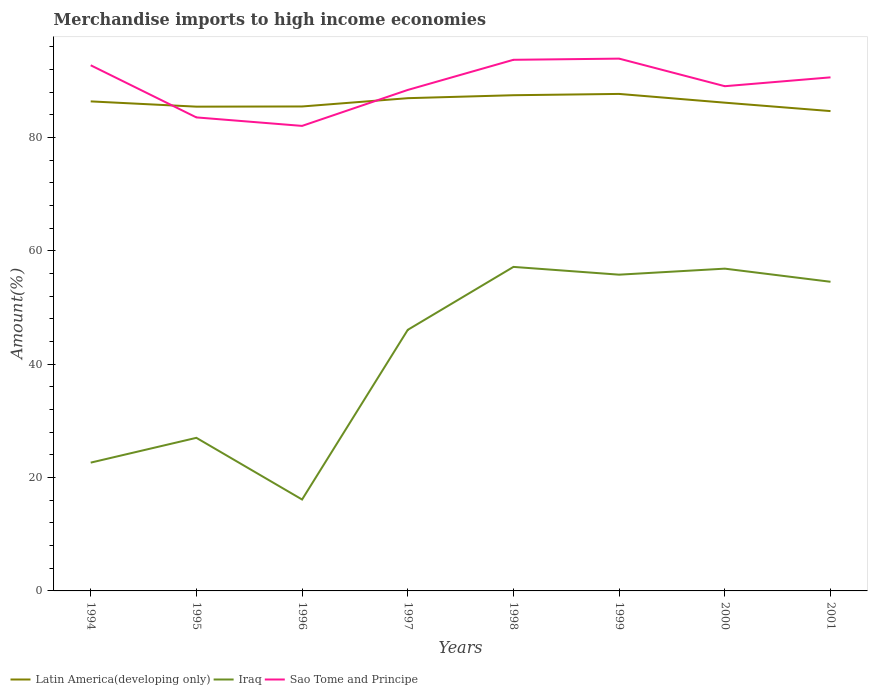Does the line corresponding to Sao Tome and Principe intersect with the line corresponding to Latin America(developing only)?
Provide a short and direct response. Yes. Across all years, what is the maximum percentage of amount earned from merchandise imports in Sao Tome and Principe?
Make the answer very short. 82.06. What is the total percentage of amount earned from merchandise imports in Sao Tome and Principe in the graph?
Provide a short and direct response. 10.7. What is the difference between the highest and the second highest percentage of amount earned from merchandise imports in Sao Tome and Principe?
Ensure brevity in your answer.  11.87. Is the percentage of amount earned from merchandise imports in Sao Tome and Principe strictly greater than the percentage of amount earned from merchandise imports in Latin America(developing only) over the years?
Provide a succinct answer. No. How many lines are there?
Provide a short and direct response. 3. How many years are there in the graph?
Ensure brevity in your answer.  8. Where does the legend appear in the graph?
Offer a very short reply. Bottom left. How are the legend labels stacked?
Keep it short and to the point. Horizontal. What is the title of the graph?
Keep it short and to the point. Merchandise imports to high income economies. What is the label or title of the X-axis?
Your answer should be compact. Years. What is the label or title of the Y-axis?
Provide a short and direct response. Amount(%). What is the Amount(%) of Latin America(developing only) in 1994?
Your answer should be very brief. 86.39. What is the Amount(%) of Iraq in 1994?
Your answer should be very brief. 22.64. What is the Amount(%) in Sao Tome and Principe in 1994?
Provide a short and direct response. 92.76. What is the Amount(%) in Latin America(developing only) in 1995?
Make the answer very short. 85.46. What is the Amount(%) in Iraq in 1995?
Your answer should be very brief. 27.02. What is the Amount(%) in Sao Tome and Principe in 1995?
Provide a short and direct response. 83.56. What is the Amount(%) of Latin America(developing only) in 1996?
Your answer should be compact. 85.49. What is the Amount(%) of Iraq in 1996?
Your response must be concise. 16.13. What is the Amount(%) of Sao Tome and Principe in 1996?
Your answer should be compact. 82.06. What is the Amount(%) in Latin America(developing only) in 1997?
Make the answer very short. 86.96. What is the Amount(%) of Iraq in 1997?
Offer a very short reply. 46.07. What is the Amount(%) of Sao Tome and Principe in 1997?
Provide a succinct answer. 88.41. What is the Amount(%) of Latin America(developing only) in 1998?
Provide a succinct answer. 87.48. What is the Amount(%) in Iraq in 1998?
Your answer should be very brief. 57.18. What is the Amount(%) in Sao Tome and Principe in 1998?
Offer a very short reply. 93.73. What is the Amount(%) of Latin America(developing only) in 1999?
Ensure brevity in your answer.  87.71. What is the Amount(%) in Iraq in 1999?
Provide a succinct answer. 55.81. What is the Amount(%) of Sao Tome and Principe in 1999?
Your response must be concise. 93.94. What is the Amount(%) of Latin America(developing only) in 2000?
Give a very brief answer. 86.16. What is the Amount(%) of Iraq in 2000?
Offer a terse response. 56.87. What is the Amount(%) of Sao Tome and Principe in 2000?
Provide a short and direct response. 89.07. What is the Amount(%) of Latin America(developing only) in 2001?
Your answer should be compact. 84.68. What is the Amount(%) in Iraq in 2001?
Your answer should be very brief. 54.56. What is the Amount(%) in Sao Tome and Principe in 2001?
Provide a short and direct response. 90.63. Across all years, what is the maximum Amount(%) of Latin America(developing only)?
Provide a succinct answer. 87.71. Across all years, what is the maximum Amount(%) of Iraq?
Give a very brief answer. 57.18. Across all years, what is the maximum Amount(%) in Sao Tome and Principe?
Offer a terse response. 93.94. Across all years, what is the minimum Amount(%) in Latin America(developing only)?
Offer a terse response. 84.68. Across all years, what is the minimum Amount(%) of Iraq?
Offer a terse response. 16.13. Across all years, what is the minimum Amount(%) in Sao Tome and Principe?
Your response must be concise. 82.06. What is the total Amount(%) of Latin America(developing only) in the graph?
Provide a succinct answer. 690.32. What is the total Amount(%) of Iraq in the graph?
Offer a very short reply. 336.28. What is the total Amount(%) of Sao Tome and Principe in the graph?
Your response must be concise. 714.16. What is the difference between the Amount(%) in Latin America(developing only) in 1994 and that in 1995?
Provide a succinct answer. 0.93. What is the difference between the Amount(%) in Iraq in 1994 and that in 1995?
Your answer should be very brief. -4.38. What is the difference between the Amount(%) of Sao Tome and Principe in 1994 and that in 1995?
Provide a succinct answer. 9.2. What is the difference between the Amount(%) of Latin America(developing only) in 1994 and that in 1996?
Give a very brief answer. 0.9. What is the difference between the Amount(%) in Iraq in 1994 and that in 1996?
Provide a succinct answer. 6.51. What is the difference between the Amount(%) in Sao Tome and Principe in 1994 and that in 1996?
Make the answer very short. 10.7. What is the difference between the Amount(%) in Latin America(developing only) in 1994 and that in 1997?
Offer a terse response. -0.57. What is the difference between the Amount(%) of Iraq in 1994 and that in 1997?
Give a very brief answer. -23.43. What is the difference between the Amount(%) in Sao Tome and Principe in 1994 and that in 1997?
Ensure brevity in your answer.  4.35. What is the difference between the Amount(%) of Latin America(developing only) in 1994 and that in 1998?
Provide a short and direct response. -1.09. What is the difference between the Amount(%) in Iraq in 1994 and that in 1998?
Give a very brief answer. -34.54. What is the difference between the Amount(%) in Sao Tome and Principe in 1994 and that in 1998?
Your answer should be very brief. -0.97. What is the difference between the Amount(%) of Latin America(developing only) in 1994 and that in 1999?
Keep it short and to the point. -1.32. What is the difference between the Amount(%) of Iraq in 1994 and that in 1999?
Your answer should be compact. -33.17. What is the difference between the Amount(%) in Sao Tome and Principe in 1994 and that in 1999?
Make the answer very short. -1.17. What is the difference between the Amount(%) in Latin America(developing only) in 1994 and that in 2000?
Your response must be concise. 0.23. What is the difference between the Amount(%) in Iraq in 1994 and that in 2000?
Your answer should be very brief. -34.23. What is the difference between the Amount(%) in Sao Tome and Principe in 1994 and that in 2000?
Provide a succinct answer. 3.69. What is the difference between the Amount(%) of Latin America(developing only) in 1994 and that in 2001?
Ensure brevity in your answer.  1.71. What is the difference between the Amount(%) in Iraq in 1994 and that in 2001?
Your answer should be very brief. -31.92. What is the difference between the Amount(%) of Sao Tome and Principe in 1994 and that in 2001?
Ensure brevity in your answer.  2.13. What is the difference between the Amount(%) of Latin America(developing only) in 1995 and that in 1996?
Your answer should be very brief. -0.03. What is the difference between the Amount(%) in Iraq in 1995 and that in 1996?
Your answer should be very brief. 10.89. What is the difference between the Amount(%) of Sao Tome and Principe in 1995 and that in 1996?
Offer a terse response. 1.5. What is the difference between the Amount(%) in Latin America(developing only) in 1995 and that in 1997?
Provide a succinct answer. -1.5. What is the difference between the Amount(%) in Iraq in 1995 and that in 1997?
Your answer should be compact. -19.06. What is the difference between the Amount(%) in Sao Tome and Principe in 1995 and that in 1997?
Make the answer very short. -4.85. What is the difference between the Amount(%) in Latin America(developing only) in 1995 and that in 1998?
Offer a very short reply. -2.02. What is the difference between the Amount(%) in Iraq in 1995 and that in 1998?
Offer a terse response. -30.17. What is the difference between the Amount(%) in Sao Tome and Principe in 1995 and that in 1998?
Provide a succinct answer. -10.17. What is the difference between the Amount(%) in Latin America(developing only) in 1995 and that in 1999?
Keep it short and to the point. -2.25. What is the difference between the Amount(%) of Iraq in 1995 and that in 1999?
Provide a short and direct response. -28.79. What is the difference between the Amount(%) of Sao Tome and Principe in 1995 and that in 1999?
Provide a succinct answer. -10.37. What is the difference between the Amount(%) of Latin America(developing only) in 1995 and that in 2000?
Your answer should be compact. -0.7. What is the difference between the Amount(%) in Iraq in 1995 and that in 2000?
Your response must be concise. -29.86. What is the difference between the Amount(%) in Sao Tome and Principe in 1995 and that in 2000?
Provide a short and direct response. -5.51. What is the difference between the Amount(%) in Latin America(developing only) in 1995 and that in 2001?
Offer a very short reply. 0.78. What is the difference between the Amount(%) in Iraq in 1995 and that in 2001?
Give a very brief answer. -27.54. What is the difference between the Amount(%) of Sao Tome and Principe in 1995 and that in 2001?
Keep it short and to the point. -7.07. What is the difference between the Amount(%) in Latin America(developing only) in 1996 and that in 1997?
Ensure brevity in your answer.  -1.46. What is the difference between the Amount(%) in Iraq in 1996 and that in 1997?
Offer a terse response. -29.94. What is the difference between the Amount(%) in Sao Tome and Principe in 1996 and that in 1997?
Your response must be concise. -6.34. What is the difference between the Amount(%) in Latin America(developing only) in 1996 and that in 1998?
Make the answer very short. -1.99. What is the difference between the Amount(%) of Iraq in 1996 and that in 1998?
Offer a terse response. -41.05. What is the difference between the Amount(%) in Sao Tome and Principe in 1996 and that in 1998?
Keep it short and to the point. -11.67. What is the difference between the Amount(%) of Latin America(developing only) in 1996 and that in 1999?
Provide a succinct answer. -2.22. What is the difference between the Amount(%) in Iraq in 1996 and that in 1999?
Offer a terse response. -39.68. What is the difference between the Amount(%) of Sao Tome and Principe in 1996 and that in 1999?
Provide a short and direct response. -11.87. What is the difference between the Amount(%) of Latin America(developing only) in 1996 and that in 2000?
Offer a terse response. -0.67. What is the difference between the Amount(%) in Iraq in 1996 and that in 2000?
Ensure brevity in your answer.  -40.74. What is the difference between the Amount(%) of Sao Tome and Principe in 1996 and that in 2000?
Offer a terse response. -7. What is the difference between the Amount(%) in Latin America(developing only) in 1996 and that in 2001?
Offer a very short reply. 0.81. What is the difference between the Amount(%) of Iraq in 1996 and that in 2001?
Your answer should be compact. -38.43. What is the difference between the Amount(%) of Sao Tome and Principe in 1996 and that in 2001?
Provide a short and direct response. -8.57. What is the difference between the Amount(%) in Latin America(developing only) in 1997 and that in 1998?
Make the answer very short. -0.52. What is the difference between the Amount(%) in Iraq in 1997 and that in 1998?
Provide a succinct answer. -11.11. What is the difference between the Amount(%) in Sao Tome and Principe in 1997 and that in 1998?
Ensure brevity in your answer.  -5.32. What is the difference between the Amount(%) of Latin America(developing only) in 1997 and that in 1999?
Keep it short and to the point. -0.75. What is the difference between the Amount(%) of Iraq in 1997 and that in 1999?
Make the answer very short. -9.74. What is the difference between the Amount(%) of Sao Tome and Principe in 1997 and that in 1999?
Your response must be concise. -5.53. What is the difference between the Amount(%) in Latin America(developing only) in 1997 and that in 2000?
Keep it short and to the point. 0.79. What is the difference between the Amount(%) in Iraq in 1997 and that in 2000?
Your answer should be compact. -10.8. What is the difference between the Amount(%) in Sao Tome and Principe in 1997 and that in 2000?
Provide a short and direct response. -0.66. What is the difference between the Amount(%) in Latin America(developing only) in 1997 and that in 2001?
Provide a succinct answer. 2.28. What is the difference between the Amount(%) of Iraq in 1997 and that in 2001?
Keep it short and to the point. -8.48. What is the difference between the Amount(%) in Sao Tome and Principe in 1997 and that in 2001?
Your response must be concise. -2.22. What is the difference between the Amount(%) in Latin America(developing only) in 1998 and that in 1999?
Offer a terse response. -0.23. What is the difference between the Amount(%) of Iraq in 1998 and that in 1999?
Your answer should be very brief. 1.37. What is the difference between the Amount(%) in Sao Tome and Principe in 1998 and that in 1999?
Give a very brief answer. -0.21. What is the difference between the Amount(%) in Latin America(developing only) in 1998 and that in 2000?
Your answer should be compact. 1.32. What is the difference between the Amount(%) of Iraq in 1998 and that in 2000?
Keep it short and to the point. 0.31. What is the difference between the Amount(%) of Sao Tome and Principe in 1998 and that in 2000?
Provide a short and direct response. 4.66. What is the difference between the Amount(%) of Latin America(developing only) in 1998 and that in 2001?
Keep it short and to the point. 2.8. What is the difference between the Amount(%) in Iraq in 1998 and that in 2001?
Your response must be concise. 2.62. What is the difference between the Amount(%) in Sao Tome and Principe in 1998 and that in 2001?
Your answer should be very brief. 3.1. What is the difference between the Amount(%) of Latin America(developing only) in 1999 and that in 2000?
Offer a very short reply. 1.54. What is the difference between the Amount(%) in Iraq in 1999 and that in 2000?
Give a very brief answer. -1.06. What is the difference between the Amount(%) in Sao Tome and Principe in 1999 and that in 2000?
Your answer should be compact. 4.87. What is the difference between the Amount(%) in Latin America(developing only) in 1999 and that in 2001?
Provide a short and direct response. 3.03. What is the difference between the Amount(%) in Iraq in 1999 and that in 2001?
Your answer should be compact. 1.25. What is the difference between the Amount(%) in Sao Tome and Principe in 1999 and that in 2001?
Your answer should be compact. 3.31. What is the difference between the Amount(%) in Latin America(developing only) in 2000 and that in 2001?
Offer a very short reply. 1.48. What is the difference between the Amount(%) in Iraq in 2000 and that in 2001?
Keep it short and to the point. 2.32. What is the difference between the Amount(%) of Sao Tome and Principe in 2000 and that in 2001?
Provide a short and direct response. -1.56. What is the difference between the Amount(%) of Latin America(developing only) in 1994 and the Amount(%) of Iraq in 1995?
Make the answer very short. 59.37. What is the difference between the Amount(%) in Latin America(developing only) in 1994 and the Amount(%) in Sao Tome and Principe in 1995?
Provide a short and direct response. 2.83. What is the difference between the Amount(%) in Iraq in 1994 and the Amount(%) in Sao Tome and Principe in 1995?
Your answer should be compact. -60.92. What is the difference between the Amount(%) in Latin America(developing only) in 1994 and the Amount(%) in Iraq in 1996?
Your answer should be very brief. 70.26. What is the difference between the Amount(%) of Latin America(developing only) in 1994 and the Amount(%) of Sao Tome and Principe in 1996?
Give a very brief answer. 4.32. What is the difference between the Amount(%) of Iraq in 1994 and the Amount(%) of Sao Tome and Principe in 1996?
Make the answer very short. -59.42. What is the difference between the Amount(%) in Latin America(developing only) in 1994 and the Amount(%) in Iraq in 1997?
Give a very brief answer. 40.32. What is the difference between the Amount(%) of Latin America(developing only) in 1994 and the Amount(%) of Sao Tome and Principe in 1997?
Ensure brevity in your answer.  -2.02. What is the difference between the Amount(%) of Iraq in 1994 and the Amount(%) of Sao Tome and Principe in 1997?
Your answer should be compact. -65.77. What is the difference between the Amount(%) of Latin America(developing only) in 1994 and the Amount(%) of Iraq in 1998?
Your response must be concise. 29.21. What is the difference between the Amount(%) of Latin America(developing only) in 1994 and the Amount(%) of Sao Tome and Principe in 1998?
Your answer should be very brief. -7.34. What is the difference between the Amount(%) of Iraq in 1994 and the Amount(%) of Sao Tome and Principe in 1998?
Offer a very short reply. -71.09. What is the difference between the Amount(%) in Latin America(developing only) in 1994 and the Amount(%) in Iraq in 1999?
Give a very brief answer. 30.58. What is the difference between the Amount(%) in Latin America(developing only) in 1994 and the Amount(%) in Sao Tome and Principe in 1999?
Make the answer very short. -7.55. What is the difference between the Amount(%) in Iraq in 1994 and the Amount(%) in Sao Tome and Principe in 1999?
Offer a very short reply. -71.3. What is the difference between the Amount(%) in Latin America(developing only) in 1994 and the Amount(%) in Iraq in 2000?
Make the answer very short. 29.52. What is the difference between the Amount(%) in Latin America(developing only) in 1994 and the Amount(%) in Sao Tome and Principe in 2000?
Offer a very short reply. -2.68. What is the difference between the Amount(%) of Iraq in 1994 and the Amount(%) of Sao Tome and Principe in 2000?
Ensure brevity in your answer.  -66.43. What is the difference between the Amount(%) of Latin America(developing only) in 1994 and the Amount(%) of Iraq in 2001?
Your response must be concise. 31.83. What is the difference between the Amount(%) in Latin America(developing only) in 1994 and the Amount(%) in Sao Tome and Principe in 2001?
Offer a terse response. -4.24. What is the difference between the Amount(%) of Iraq in 1994 and the Amount(%) of Sao Tome and Principe in 2001?
Offer a very short reply. -67.99. What is the difference between the Amount(%) of Latin America(developing only) in 1995 and the Amount(%) of Iraq in 1996?
Ensure brevity in your answer.  69.33. What is the difference between the Amount(%) of Latin America(developing only) in 1995 and the Amount(%) of Sao Tome and Principe in 1996?
Keep it short and to the point. 3.4. What is the difference between the Amount(%) in Iraq in 1995 and the Amount(%) in Sao Tome and Principe in 1996?
Provide a short and direct response. -55.05. What is the difference between the Amount(%) of Latin America(developing only) in 1995 and the Amount(%) of Iraq in 1997?
Ensure brevity in your answer.  39.39. What is the difference between the Amount(%) of Latin America(developing only) in 1995 and the Amount(%) of Sao Tome and Principe in 1997?
Provide a succinct answer. -2.95. What is the difference between the Amount(%) of Iraq in 1995 and the Amount(%) of Sao Tome and Principe in 1997?
Your response must be concise. -61.39. What is the difference between the Amount(%) in Latin America(developing only) in 1995 and the Amount(%) in Iraq in 1998?
Provide a succinct answer. 28.28. What is the difference between the Amount(%) in Latin America(developing only) in 1995 and the Amount(%) in Sao Tome and Principe in 1998?
Give a very brief answer. -8.27. What is the difference between the Amount(%) in Iraq in 1995 and the Amount(%) in Sao Tome and Principe in 1998?
Make the answer very short. -66.71. What is the difference between the Amount(%) in Latin America(developing only) in 1995 and the Amount(%) in Iraq in 1999?
Offer a terse response. 29.65. What is the difference between the Amount(%) in Latin America(developing only) in 1995 and the Amount(%) in Sao Tome and Principe in 1999?
Give a very brief answer. -8.48. What is the difference between the Amount(%) of Iraq in 1995 and the Amount(%) of Sao Tome and Principe in 1999?
Your answer should be very brief. -66.92. What is the difference between the Amount(%) of Latin America(developing only) in 1995 and the Amount(%) of Iraq in 2000?
Provide a short and direct response. 28.59. What is the difference between the Amount(%) of Latin America(developing only) in 1995 and the Amount(%) of Sao Tome and Principe in 2000?
Ensure brevity in your answer.  -3.61. What is the difference between the Amount(%) of Iraq in 1995 and the Amount(%) of Sao Tome and Principe in 2000?
Ensure brevity in your answer.  -62.05. What is the difference between the Amount(%) in Latin America(developing only) in 1995 and the Amount(%) in Iraq in 2001?
Provide a succinct answer. 30.9. What is the difference between the Amount(%) in Latin America(developing only) in 1995 and the Amount(%) in Sao Tome and Principe in 2001?
Your answer should be compact. -5.17. What is the difference between the Amount(%) of Iraq in 1995 and the Amount(%) of Sao Tome and Principe in 2001?
Provide a short and direct response. -63.62. What is the difference between the Amount(%) of Latin America(developing only) in 1996 and the Amount(%) of Iraq in 1997?
Your answer should be very brief. 39.42. What is the difference between the Amount(%) of Latin America(developing only) in 1996 and the Amount(%) of Sao Tome and Principe in 1997?
Your response must be concise. -2.92. What is the difference between the Amount(%) in Iraq in 1996 and the Amount(%) in Sao Tome and Principe in 1997?
Keep it short and to the point. -72.28. What is the difference between the Amount(%) in Latin America(developing only) in 1996 and the Amount(%) in Iraq in 1998?
Make the answer very short. 28.31. What is the difference between the Amount(%) of Latin America(developing only) in 1996 and the Amount(%) of Sao Tome and Principe in 1998?
Keep it short and to the point. -8.24. What is the difference between the Amount(%) of Iraq in 1996 and the Amount(%) of Sao Tome and Principe in 1998?
Ensure brevity in your answer.  -77.6. What is the difference between the Amount(%) in Latin America(developing only) in 1996 and the Amount(%) in Iraq in 1999?
Your answer should be compact. 29.68. What is the difference between the Amount(%) in Latin America(developing only) in 1996 and the Amount(%) in Sao Tome and Principe in 1999?
Give a very brief answer. -8.45. What is the difference between the Amount(%) in Iraq in 1996 and the Amount(%) in Sao Tome and Principe in 1999?
Give a very brief answer. -77.81. What is the difference between the Amount(%) of Latin America(developing only) in 1996 and the Amount(%) of Iraq in 2000?
Make the answer very short. 28.62. What is the difference between the Amount(%) of Latin America(developing only) in 1996 and the Amount(%) of Sao Tome and Principe in 2000?
Provide a succinct answer. -3.58. What is the difference between the Amount(%) in Iraq in 1996 and the Amount(%) in Sao Tome and Principe in 2000?
Keep it short and to the point. -72.94. What is the difference between the Amount(%) in Latin America(developing only) in 1996 and the Amount(%) in Iraq in 2001?
Your answer should be compact. 30.93. What is the difference between the Amount(%) of Latin America(developing only) in 1996 and the Amount(%) of Sao Tome and Principe in 2001?
Keep it short and to the point. -5.14. What is the difference between the Amount(%) of Iraq in 1996 and the Amount(%) of Sao Tome and Principe in 2001?
Offer a very short reply. -74.5. What is the difference between the Amount(%) of Latin America(developing only) in 1997 and the Amount(%) of Iraq in 1998?
Make the answer very short. 29.77. What is the difference between the Amount(%) of Latin America(developing only) in 1997 and the Amount(%) of Sao Tome and Principe in 1998?
Ensure brevity in your answer.  -6.77. What is the difference between the Amount(%) in Iraq in 1997 and the Amount(%) in Sao Tome and Principe in 1998?
Ensure brevity in your answer.  -47.66. What is the difference between the Amount(%) in Latin America(developing only) in 1997 and the Amount(%) in Iraq in 1999?
Offer a very short reply. 31.15. What is the difference between the Amount(%) in Latin America(developing only) in 1997 and the Amount(%) in Sao Tome and Principe in 1999?
Make the answer very short. -6.98. What is the difference between the Amount(%) of Iraq in 1997 and the Amount(%) of Sao Tome and Principe in 1999?
Give a very brief answer. -47.86. What is the difference between the Amount(%) of Latin America(developing only) in 1997 and the Amount(%) of Iraq in 2000?
Provide a short and direct response. 30.08. What is the difference between the Amount(%) of Latin America(developing only) in 1997 and the Amount(%) of Sao Tome and Principe in 2000?
Keep it short and to the point. -2.11. What is the difference between the Amount(%) of Iraq in 1997 and the Amount(%) of Sao Tome and Principe in 2000?
Your answer should be very brief. -43. What is the difference between the Amount(%) in Latin America(developing only) in 1997 and the Amount(%) in Iraq in 2001?
Your answer should be very brief. 32.4. What is the difference between the Amount(%) in Latin America(developing only) in 1997 and the Amount(%) in Sao Tome and Principe in 2001?
Offer a terse response. -3.68. What is the difference between the Amount(%) of Iraq in 1997 and the Amount(%) of Sao Tome and Principe in 2001?
Give a very brief answer. -44.56. What is the difference between the Amount(%) of Latin America(developing only) in 1998 and the Amount(%) of Iraq in 1999?
Offer a very short reply. 31.67. What is the difference between the Amount(%) in Latin America(developing only) in 1998 and the Amount(%) in Sao Tome and Principe in 1999?
Make the answer very short. -6.46. What is the difference between the Amount(%) in Iraq in 1998 and the Amount(%) in Sao Tome and Principe in 1999?
Offer a terse response. -36.76. What is the difference between the Amount(%) of Latin America(developing only) in 1998 and the Amount(%) of Iraq in 2000?
Offer a very short reply. 30.6. What is the difference between the Amount(%) of Latin America(developing only) in 1998 and the Amount(%) of Sao Tome and Principe in 2000?
Keep it short and to the point. -1.59. What is the difference between the Amount(%) of Iraq in 1998 and the Amount(%) of Sao Tome and Principe in 2000?
Your response must be concise. -31.89. What is the difference between the Amount(%) of Latin America(developing only) in 1998 and the Amount(%) of Iraq in 2001?
Ensure brevity in your answer.  32.92. What is the difference between the Amount(%) of Latin America(developing only) in 1998 and the Amount(%) of Sao Tome and Principe in 2001?
Offer a terse response. -3.15. What is the difference between the Amount(%) of Iraq in 1998 and the Amount(%) of Sao Tome and Principe in 2001?
Provide a short and direct response. -33.45. What is the difference between the Amount(%) in Latin America(developing only) in 1999 and the Amount(%) in Iraq in 2000?
Your answer should be very brief. 30.83. What is the difference between the Amount(%) of Latin America(developing only) in 1999 and the Amount(%) of Sao Tome and Principe in 2000?
Your answer should be very brief. -1.36. What is the difference between the Amount(%) of Iraq in 1999 and the Amount(%) of Sao Tome and Principe in 2000?
Ensure brevity in your answer.  -33.26. What is the difference between the Amount(%) in Latin America(developing only) in 1999 and the Amount(%) in Iraq in 2001?
Offer a terse response. 33.15. What is the difference between the Amount(%) of Latin America(developing only) in 1999 and the Amount(%) of Sao Tome and Principe in 2001?
Your answer should be very brief. -2.92. What is the difference between the Amount(%) of Iraq in 1999 and the Amount(%) of Sao Tome and Principe in 2001?
Keep it short and to the point. -34.82. What is the difference between the Amount(%) of Latin America(developing only) in 2000 and the Amount(%) of Iraq in 2001?
Give a very brief answer. 31.61. What is the difference between the Amount(%) in Latin America(developing only) in 2000 and the Amount(%) in Sao Tome and Principe in 2001?
Your answer should be very brief. -4.47. What is the difference between the Amount(%) of Iraq in 2000 and the Amount(%) of Sao Tome and Principe in 2001?
Provide a short and direct response. -33.76. What is the average Amount(%) in Latin America(developing only) per year?
Your answer should be compact. 86.29. What is the average Amount(%) of Iraq per year?
Ensure brevity in your answer.  42.04. What is the average Amount(%) of Sao Tome and Principe per year?
Your response must be concise. 89.27. In the year 1994, what is the difference between the Amount(%) in Latin America(developing only) and Amount(%) in Iraq?
Offer a very short reply. 63.75. In the year 1994, what is the difference between the Amount(%) of Latin America(developing only) and Amount(%) of Sao Tome and Principe?
Provide a succinct answer. -6.37. In the year 1994, what is the difference between the Amount(%) of Iraq and Amount(%) of Sao Tome and Principe?
Provide a succinct answer. -70.12. In the year 1995, what is the difference between the Amount(%) of Latin America(developing only) and Amount(%) of Iraq?
Offer a terse response. 58.44. In the year 1995, what is the difference between the Amount(%) in Latin America(developing only) and Amount(%) in Sao Tome and Principe?
Give a very brief answer. 1.9. In the year 1995, what is the difference between the Amount(%) in Iraq and Amount(%) in Sao Tome and Principe?
Provide a short and direct response. -56.55. In the year 1996, what is the difference between the Amount(%) in Latin America(developing only) and Amount(%) in Iraq?
Provide a succinct answer. 69.36. In the year 1996, what is the difference between the Amount(%) of Latin America(developing only) and Amount(%) of Sao Tome and Principe?
Keep it short and to the point. 3.43. In the year 1996, what is the difference between the Amount(%) in Iraq and Amount(%) in Sao Tome and Principe?
Your response must be concise. -65.93. In the year 1997, what is the difference between the Amount(%) in Latin America(developing only) and Amount(%) in Iraq?
Provide a succinct answer. 40.88. In the year 1997, what is the difference between the Amount(%) in Latin America(developing only) and Amount(%) in Sao Tome and Principe?
Your response must be concise. -1.45. In the year 1997, what is the difference between the Amount(%) in Iraq and Amount(%) in Sao Tome and Principe?
Offer a terse response. -42.34. In the year 1998, what is the difference between the Amount(%) of Latin America(developing only) and Amount(%) of Iraq?
Offer a terse response. 30.3. In the year 1998, what is the difference between the Amount(%) in Latin America(developing only) and Amount(%) in Sao Tome and Principe?
Your answer should be compact. -6.25. In the year 1998, what is the difference between the Amount(%) of Iraq and Amount(%) of Sao Tome and Principe?
Give a very brief answer. -36.55. In the year 1999, what is the difference between the Amount(%) in Latin America(developing only) and Amount(%) in Iraq?
Offer a terse response. 31.9. In the year 1999, what is the difference between the Amount(%) in Latin America(developing only) and Amount(%) in Sao Tome and Principe?
Your response must be concise. -6.23. In the year 1999, what is the difference between the Amount(%) of Iraq and Amount(%) of Sao Tome and Principe?
Give a very brief answer. -38.13. In the year 2000, what is the difference between the Amount(%) of Latin America(developing only) and Amount(%) of Iraq?
Your answer should be compact. 29.29. In the year 2000, what is the difference between the Amount(%) of Latin America(developing only) and Amount(%) of Sao Tome and Principe?
Provide a short and direct response. -2.91. In the year 2000, what is the difference between the Amount(%) of Iraq and Amount(%) of Sao Tome and Principe?
Offer a very short reply. -32.2. In the year 2001, what is the difference between the Amount(%) in Latin America(developing only) and Amount(%) in Iraq?
Make the answer very short. 30.12. In the year 2001, what is the difference between the Amount(%) in Latin America(developing only) and Amount(%) in Sao Tome and Principe?
Keep it short and to the point. -5.95. In the year 2001, what is the difference between the Amount(%) in Iraq and Amount(%) in Sao Tome and Principe?
Offer a terse response. -36.07. What is the ratio of the Amount(%) in Latin America(developing only) in 1994 to that in 1995?
Give a very brief answer. 1.01. What is the ratio of the Amount(%) of Iraq in 1994 to that in 1995?
Give a very brief answer. 0.84. What is the ratio of the Amount(%) in Sao Tome and Principe in 1994 to that in 1995?
Keep it short and to the point. 1.11. What is the ratio of the Amount(%) in Latin America(developing only) in 1994 to that in 1996?
Make the answer very short. 1.01. What is the ratio of the Amount(%) in Iraq in 1994 to that in 1996?
Keep it short and to the point. 1.4. What is the ratio of the Amount(%) in Sao Tome and Principe in 1994 to that in 1996?
Offer a terse response. 1.13. What is the ratio of the Amount(%) in Latin America(developing only) in 1994 to that in 1997?
Offer a very short reply. 0.99. What is the ratio of the Amount(%) of Iraq in 1994 to that in 1997?
Keep it short and to the point. 0.49. What is the ratio of the Amount(%) of Sao Tome and Principe in 1994 to that in 1997?
Provide a succinct answer. 1.05. What is the ratio of the Amount(%) in Latin America(developing only) in 1994 to that in 1998?
Offer a terse response. 0.99. What is the ratio of the Amount(%) in Iraq in 1994 to that in 1998?
Your answer should be compact. 0.4. What is the ratio of the Amount(%) in Sao Tome and Principe in 1994 to that in 1998?
Keep it short and to the point. 0.99. What is the ratio of the Amount(%) in Iraq in 1994 to that in 1999?
Ensure brevity in your answer.  0.41. What is the ratio of the Amount(%) in Sao Tome and Principe in 1994 to that in 1999?
Give a very brief answer. 0.99. What is the ratio of the Amount(%) in Latin America(developing only) in 1994 to that in 2000?
Keep it short and to the point. 1. What is the ratio of the Amount(%) of Iraq in 1994 to that in 2000?
Ensure brevity in your answer.  0.4. What is the ratio of the Amount(%) in Sao Tome and Principe in 1994 to that in 2000?
Give a very brief answer. 1.04. What is the ratio of the Amount(%) in Latin America(developing only) in 1994 to that in 2001?
Make the answer very short. 1.02. What is the ratio of the Amount(%) of Iraq in 1994 to that in 2001?
Make the answer very short. 0.41. What is the ratio of the Amount(%) in Sao Tome and Principe in 1994 to that in 2001?
Your answer should be very brief. 1.02. What is the ratio of the Amount(%) in Iraq in 1995 to that in 1996?
Ensure brevity in your answer.  1.67. What is the ratio of the Amount(%) in Sao Tome and Principe in 1995 to that in 1996?
Provide a succinct answer. 1.02. What is the ratio of the Amount(%) of Latin America(developing only) in 1995 to that in 1997?
Your response must be concise. 0.98. What is the ratio of the Amount(%) of Iraq in 1995 to that in 1997?
Provide a short and direct response. 0.59. What is the ratio of the Amount(%) of Sao Tome and Principe in 1995 to that in 1997?
Offer a terse response. 0.95. What is the ratio of the Amount(%) of Latin America(developing only) in 1995 to that in 1998?
Keep it short and to the point. 0.98. What is the ratio of the Amount(%) of Iraq in 1995 to that in 1998?
Offer a very short reply. 0.47. What is the ratio of the Amount(%) of Sao Tome and Principe in 1995 to that in 1998?
Provide a short and direct response. 0.89. What is the ratio of the Amount(%) of Latin America(developing only) in 1995 to that in 1999?
Provide a short and direct response. 0.97. What is the ratio of the Amount(%) of Iraq in 1995 to that in 1999?
Your answer should be compact. 0.48. What is the ratio of the Amount(%) in Sao Tome and Principe in 1995 to that in 1999?
Give a very brief answer. 0.89. What is the ratio of the Amount(%) of Latin America(developing only) in 1995 to that in 2000?
Your answer should be very brief. 0.99. What is the ratio of the Amount(%) in Iraq in 1995 to that in 2000?
Your answer should be very brief. 0.47. What is the ratio of the Amount(%) in Sao Tome and Principe in 1995 to that in 2000?
Keep it short and to the point. 0.94. What is the ratio of the Amount(%) in Latin America(developing only) in 1995 to that in 2001?
Keep it short and to the point. 1.01. What is the ratio of the Amount(%) in Iraq in 1995 to that in 2001?
Offer a very short reply. 0.5. What is the ratio of the Amount(%) in Sao Tome and Principe in 1995 to that in 2001?
Your answer should be compact. 0.92. What is the ratio of the Amount(%) of Latin America(developing only) in 1996 to that in 1997?
Keep it short and to the point. 0.98. What is the ratio of the Amount(%) of Iraq in 1996 to that in 1997?
Provide a succinct answer. 0.35. What is the ratio of the Amount(%) of Sao Tome and Principe in 1996 to that in 1997?
Ensure brevity in your answer.  0.93. What is the ratio of the Amount(%) of Latin America(developing only) in 1996 to that in 1998?
Keep it short and to the point. 0.98. What is the ratio of the Amount(%) in Iraq in 1996 to that in 1998?
Offer a very short reply. 0.28. What is the ratio of the Amount(%) in Sao Tome and Principe in 1996 to that in 1998?
Offer a very short reply. 0.88. What is the ratio of the Amount(%) in Latin America(developing only) in 1996 to that in 1999?
Give a very brief answer. 0.97. What is the ratio of the Amount(%) of Iraq in 1996 to that in 1999?
Provide a short and direct response. 0.29. What is the ratio of the Amount(%) of Sao Tome and Principe in 1996 to that in 1999?
Provide a short and direct response. 0.87. What is the ratio of the Amount(%) of Latin America(developing only) in 1996 to that in 2000?
Keep it short and to the point. 0.99. What is the ratio of the Amount(%) of Iraq in 1996 to that in 2000?
Your response must be concise. 0.28. What is the ratio of the Amount(%) of Sao Tome and Principe in 1996 to that in 2000?
Give a very brief answer. 0.92. What is the ratio of the Amount(%) in Latin America(developing only) in 1996 to that in 2001?
Give a very brief answer. 1.01. What is the ratio of the Amount(%) in Iraq in 1996 to that in 2001?
Your answer should be very brief. 0.3. What is the ratio of the Amount(%) of Sao Tome and Principe in 1996 to that in 2001?
Offer a very short reply. 0.91. What is the ratio of the Amount(%) of Latin America(developing only) in 1997 to that in 1998?
Your answer should be compact. 0.99. What is the ratio of the Amount(%) of Iraq in 1997 to that in 1998?
Your response must be concise. 0.81. What is the ratio of the Amount(%) of Sao Tome and Principe in 1997 to that in 1998?
Your answer should be very brief. 0.94. What is the ratio of the Amount(%) in Latin America(developing only) in 1997 to that in 1999?
Provide a short and direct response. 0.99. What is the ratio of the Amount(%) in Iraq in 1997 to that in 1999?
Your response must be concise. 0.83. What is the ratio of the Amount(%) in Latin America(developing only) in 1997 to that in 2000?
Your response must be concise. 1.01. What is the ratio of the Amount(%) in Iraq in 1997 to that in 2000?
Provide a succinct answer. 0.81. What is the ratio of the Amount(%) of Sao Tome and Principe in 1997 to that in 2000?
Offer a terse response. 0.99. What is the ratio of the Amount(%) of Latin America(developing only) in 1997 to that in 2001?
Your response must be concise. 1.03. What is the ratio of the Amount(%) of Iraq in 1997 to that in 2001?
Offer a very short reply. 0.84. What is the ratio of the Amount(%) in Sao Tome and Principe in 1997 to that in 2001?
Keep it short and to the point. 0.98. What is the ratio of the Amount(%) in Iraq in 1998 to that in 1999?
Your response must be concise. 1.02. What is the ratio of the Amount(%) in Latin America(developing only) in 1998 to that in 2000?
Provide a succinct answer. 1.02. What is the ratio of the Amount(%) of Iraq in 1998 to that in 2000?
Make the answer very short. 1.01. What is the ratio of the Amount(%) in Sao Tome and Principe in 1998 to that in 2000?
Offer a very short reply. 1.05. What is the ratio of the Amount(%) of Latin America(developing only) in 1998 to that in 2001?
Your response must be concise. 1.03. What is the ratio of the Amount(%) in Iraq in 1998 to that in 2001?
Your response must be concise. 1.05. What is the ratio of the Amount(%) in Sao Tome and Principe in 1998 to that in 2001?
Offer a terse response. 1.03. What is the ratio of the Amount(%) in Latin America(developing only) in 1999 to that in 2000?
Your answer should be very brief. 1.02. What is the ratio of the Amount(%) of Iraq in 1999 to that in 2000?
Provide a short and direct response. 0.98. What is the ratio of the Amount(%) in Sao Tome and Principe in 1999 to that in 2000?
Give a very brief answer. 1.05. What is the ratio of the Amount(%) in Latin America(developing only) in 1999 to that in 2001?
Make the answer very short. 1.04. What is the ratio of the Amount(%) in Sao Tome and Principe in 1999 to that in 2001?
Your answer should be compact. 1.04. What is the ratio of the Amount(%) in Latin America(developing only) in 2000 to that in 2001?
Provide a succinct answer. 1.02. What is the ratio of the Amount(%) in Iraq in 2000 to that in 2001?
Your response must be concise. 1.04. What is the ratio of the Amount(%) of Sao Tome and Principe in 2000 to that in 2001?
Your response must be concise. 0.98. What is the difference between the highest and the second highest Amount(%) in Latin America(developing only)?
Make the answer very short. 0.23. What is the difference between the highest and the second highest Amount(%) of Iraq?
Your response must be concise. 0.31. What is the difference between the highest and the second highest Amount(%) in Sao Tome and Principe?
Your answer should be compact. 0.21. What is the difference between the highest and the lowest Amount(%) in Latin America(developing only)?
Provide a short and direct response. 3.03. What is the difference between the highest and the lowest Amount(%) of Iraq?
Your response must be concise. 41.05. What is the difference between the highest and the lowest Amount(%) in Sao Tome and Principe?
Make the answer very short. 11.87. 